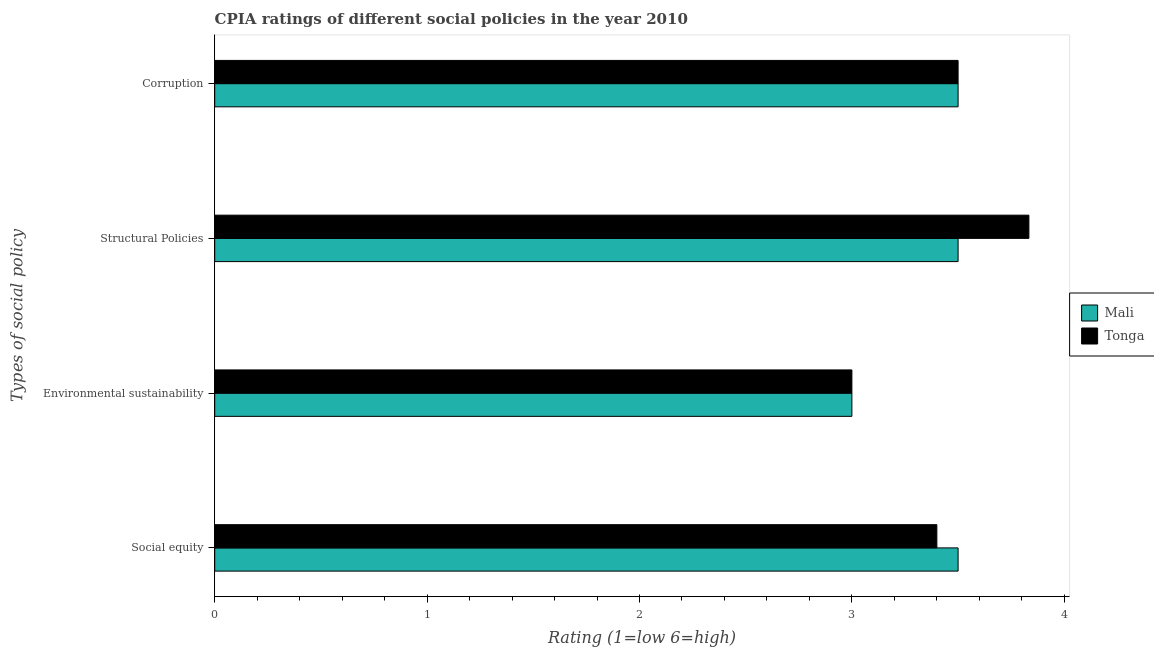How many bars are there on the 2nd tick from the top?
Your answer should be very brief. 2. What is the label of the 3rd group of bars from the top?
Provide a short and direct response. Environmental sustainability. What is the cpia rating of structural policies in Tonga?
Make the answer very short. 3.83. Across all countries, what is the minimum cpia rating of structural policies?
Ensure brevity in your answer.  3.5. In which country was the cpia rating of structural policies maximum?
Provide a short and direct response. Tonga. In which country was the cpia rating of environmental sustainability minimum?
Provide a succinct answer. Mali. What is the total cpia rating of corruption in the graph?
Ensure brevity in your answer.  7. What is the difference between the cpia rating of structural policies in Mali and the cpia rating of corruption in Tonga?
Make the answer very short. 0. What is the difference between the cpia rating of social equity and cpia rating of structural policies in Tonga?
Provide a succinct answer. -0.43. In how many countries, is the cpia rating of structural policies greater than 2.8 ?
Keep it short and to the point. 2. Is the cpia rating of corruption in Mali less than that in Tonga?
Ensure brevity in your answer.  No. Is the difference between the cpia rating of environmental sustainability in Mali and Tonga greater than the difference between the cpia rating of social equity in Mali and Tonga?
Provide a short and direct response. No. What is the difference between the highest and the second highest cpia rating of structural policies?
Make the answer very short. 0.33. In how many countries, is the cpia rating of environmental sustainability greater than the average cpia rating of environmental sustainability taken over all countries?
Give a very brief answer. 0. Is it the case that in every country, the sum of the cpia rating of social equity and cpia rating of corruption is greater than the sum of cpia rating of environmental sustainability and cpia rating of structural policies?
Keep it short and to the point. No. What does the 1st bar from the top in Corruption represents?
Provide a short and direct response. Tonga. What does the 2nd bar from the bottom in Environmental sustainability represents?
Your answer should be compact. Tonga. How many bars are there?
Offer a very short reply. 8. What is the difference between two consecutive major ticks on the X-axis?
Make the answer very short. 1. Does the graph contain any zero values?
Make the answer very short. No. Does the graph contain grids?
Offer a terse response. No. How many legend labels are there?
Ensure brevity in your answer.  2. How are the legend labels stacked?
Ensure brevity in your answer.  Vertical. What is the title of the graph?
Keep it short and to the point. CPIA ratings of different social policies in the year 2010. What is the label or title of the Y-axis?
Offer a terse response. Types of social policy. What is the Rating (1=low 6=high) of Mali in Social equity?
Offer a very short reply. 3.5. What is the Rating (1=low 6=high) of Mali in Environmental sustainability?
Your answer should be very brief. 3. What is the Rating (1=low 6=high) in Mali in Structural Policies?
Provide a short and direct response. 3.5. What is the Rating (1=low 6=high) in Tonga in Structural Policies?
Keep it short and to the point. 3.83. What is the Rating (1=low 6=high) of Tonga in Corruption?
Provide a succinct answer. 3.5. Across all Types of social policy, what is the maximum Rating (1=low 6=high) of Tonga?
Offer a very short reply. 3.83. Across all Types of social policy, what is the minimum Rating (1=low 6=high) of Mali?
Offer a very short reply. 3. Across all Types of social policy, what is the minimum Rating (1=low 6=high) of Tonga?
Give a very brief answer. 3. What is the total Rating (1=low 6=high) of Mali in the graph?
Ensure brevity in your answer.  13.5. What is the total Rating (1=low 6=high) in Tonga in the graph?
Your answer should be compact. 13.73. What is the difference between the Rating (1=low 6=high) in Mali in Social equity and that in Environmental sustainability?
Your response must be concise. 0.5. What is the difference between the Rating (1=low 6=high) in Tonga in Social equity and that in Structural Policies?
Provide a succinct answer. -0.43. What is the difference between the Rating (1=low 6=high) of Tonga in Environmental sustainability and that in Structural Policies?
Give a very brief answer. -0.83. What is the difference between the Rating (1=low 6=high) of Mali in Structural Policies and that in Corruption?
Make the answer very short. 0. What is the difference between the Rating (1=low 6=high) in Mali in Social equity and the Rating (1=low 6=high) in Tonga in Corruption?
Give a very brief answer. 0. What is the average Rating (1=low 6=high) of Mali per Types of social policy?
Make the answer very short. 3.38. What is the average Rating (1=low 6=high) of Tonga per Types of social policy?
Offer a terse response. 3.43. What is the difference between the Rating (1=low 6=high) in Mali and Rating (1=low 6=high) in Tonga in Corruption?
Offer a very short reply. 0. What is the ratio of the Rating (1=low 6=high) in Tonga in Social equity to that in Environmental sustainability?
Your answer should be very brief. 1.13. What is the ratio of the Rating (1=low 6=high) of Tonga in Social equity to that in Structural Policies?
Give a very brief answer. 0.89. What is the ratio of the Rating (1=low 6=high) of Mali in Social equity to that in Corruption?
Keep it short and to the point. 1. What is the ratio of the Rating (1=low 6=high) of Tonga in Social equity to that in Corruption?
Keep it short and to the point. 0.97. What is the ratio of the Rating (1=low 6=high) of Mali in Environmental sustainability to that in Structural Policies?
Your answer should be very brief. 0.86. What is the ratio of the Rating (1=low 6=high) in Tonga in Environmental sustainability to that in Structural Policies?
Ensure brevity in your answer.  0.78. What is the ratio of the Rating (1=low 6=high) in Mali in Environmental sustainability to that in Corruption?
Ensure brevity in your answer.  0.86. What is the ratio of the Rating (1=low 6=high) of Tonga in Structural Policies to that in Corruption?
Your answer should be compact. 1.1. What is the difference between the highest and the second highest Rating (1=low 6=high) of Mali?
Give a very brief answer. 0. What is the difference between the highest and the second highest Rating (1=low 6=high) in Tonga?
Ensure brevity in your answer.  0.33. What is the difference between the highest and the lowest Rating (1=low 6=high) of Mali?
Offer a very short reply. 0.5. What is the difference between the highest and the lowest Rating (1=low 6=high) of Tonga?
Keep it short and to the point. 0.83. 